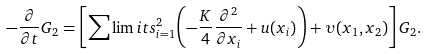Convert formula to latex. <formula><loc_0><loc_0><loc_500><loc_500>- \frac { \partial } { \partial t } G _ { 2 } = \left [ { \sum \lim i t s _ { i = 1 } ^ { 2 } { \left ( { - \frac { K } { 4 } \frac { \partial ^ { 2 } } { \partial x _ { i } } + u ( x _ { i } ) } \right ) } + \upsilon ( x _ { 1 } , x _ { 2 } ) } \right ] G _ { 2 } .</formula> 